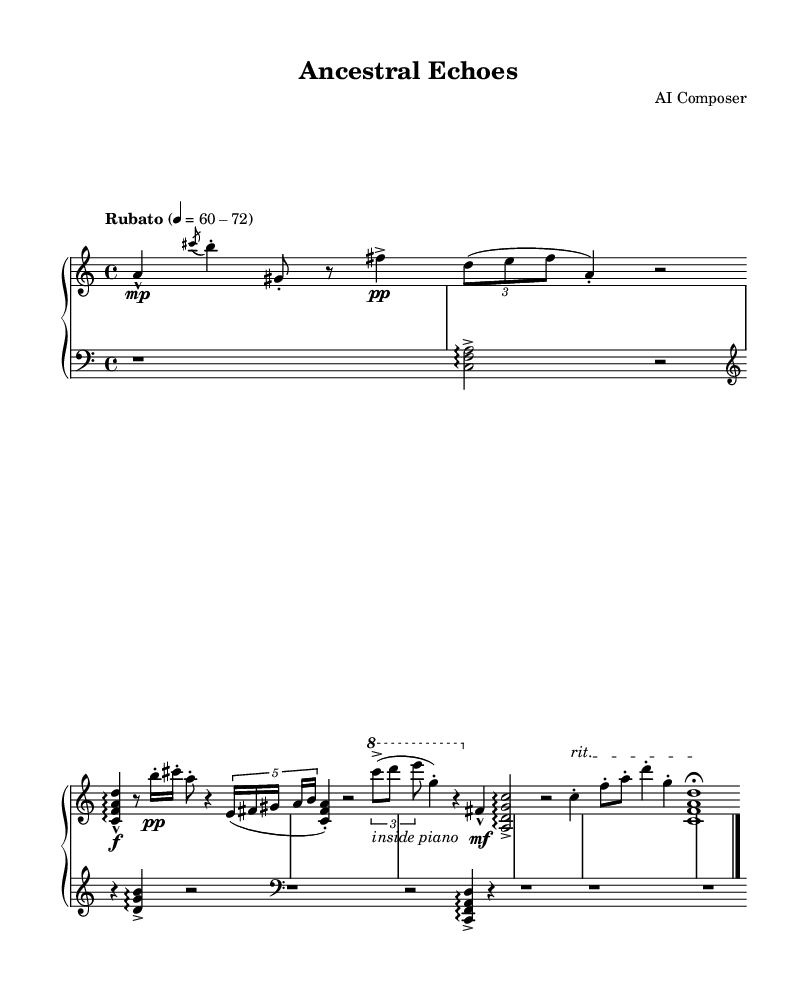What is the time signature of this music? The time signature is displayed at the beginning of the score, where "4/4" is indicated, meaning there are four beats in each measure.
Answer: 4/4 What is the tempo marking for this piece? The tempo marking is noted as "Rubato" with a metronome mark of 60-72, indicating that the piece should be played with flexible timing within that speed range.
Answer: Rubato, 60-72 How many sections are present in this piece? By examining the score, there are three distinct sections labeled as "Section A," "Section B," and the "Coda," making a total of three sections.
Answer: 3 In which clef is the right-hand part written? The right-hand part is written in the treble clef, as indicated at the beginning of the right-hand staff where the clef symbol is present.
Answer: Treble What dynamic marking appears at the start of Section A? At the start of Section A, the dynamic marking is indicated as "f" for forte, suggesting that this section should be played loudly.
Answer: f What musical technique is indicated in Section B for the right hand? In Section B, the technique marked is "inside piano," which suggests playing inside the piano, producing a unique sound by striking the strings directly.
Answer: inside piano How does the music transition into the Coda? The transition into the Coda is indicated by the text "rit.," which stands for "ritardando," instructing the player to slow down, creating a smooth transition into the final section.
Answer: rit 